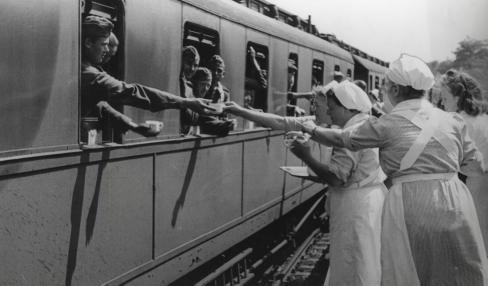How many people are visible?
Give a very brief answer. 5. How many elephants are near the rocks?
Give a very brief answer. 0. 